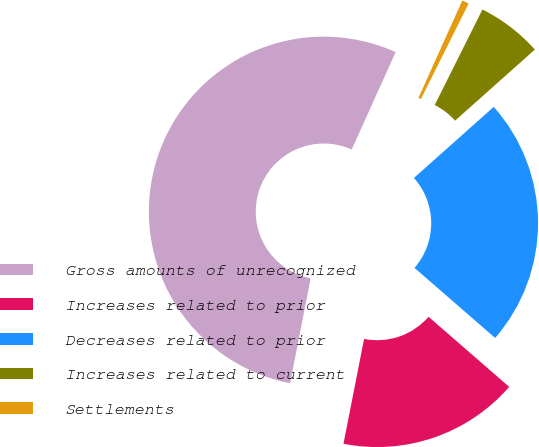Convert chart. <chart><loc_0><loc_0><loc_500><loc_500><pie_chart><fcel>Gross amounts of unrecognized<fcel>Increases related to prior<fcel>Decreases related to prior<fcel>Increases related to current<fcel>Settlements<nl><fcel>53.65%<fcel>16.7%<fcel>22.97%<fcel>6.04%<fcel>0.64%<nl></chart> 